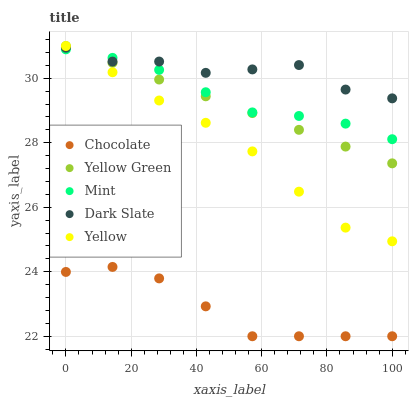Does Chocolate have the minimum area under the curve?
Answer yes or no. Yes. Does Dark Slate have the maximum area under the curve?
Answer yes or no. Yes. Does Mint have the minimum area under the curve?
Answer yes or no. No. Does Mint have the maximum area under the curve?
Answer yes or no. No. Is Yellow Green the smoothest?
Answer yes or no. Yes. Is Dark Slate the roughest?
Answer yes or no. Yes. Is Mint the smoothest?
Answer yes or no. No. Is Mint the roughest?
Answer yes or no. No. Does Chocolate have the lowest value?
Answer yes or no. Yes. Does Mint have the lowest value?
Answer yes or no. No. Does Yellow have the highest value?
Answer yes or no. Yes. Does Mint have the highest value?
Answer yes or no. No. Is Chocolate less than Yellow Green?
Answer yes or no. Yes. Is Yellow greater than Chocolate?
Answer yes or no. Yes. Does Yellow Green intersect Yellow?
Answer yes or no. Yes. Is Yellow Green less than Yellow?
Answer yes or no. No. Is Yellow Green greater than Yellow?
Answer yes or no. No. Does Chocolate intersect Yellow Green?
Answer yes or no. No. 